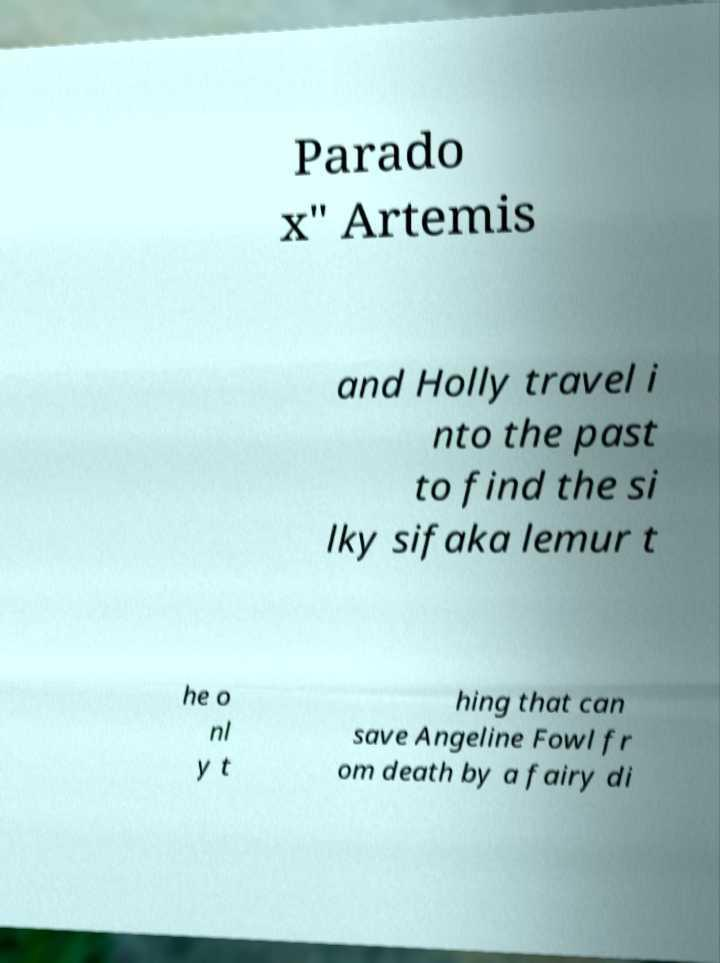Can you read and provide the text displayed in the image?This photo seems to have some interesting text. Can you extract and type it out for me? Parado x" Artemis and Holly travel i nto the past to find the si lky sifaka lemur t he o nl y t hing that can save Angeline Fowl fr om death by a fairy di 